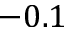<formula> <loc_0><loc_0><loc_500><loc_500>- 0 . 1</formula> 